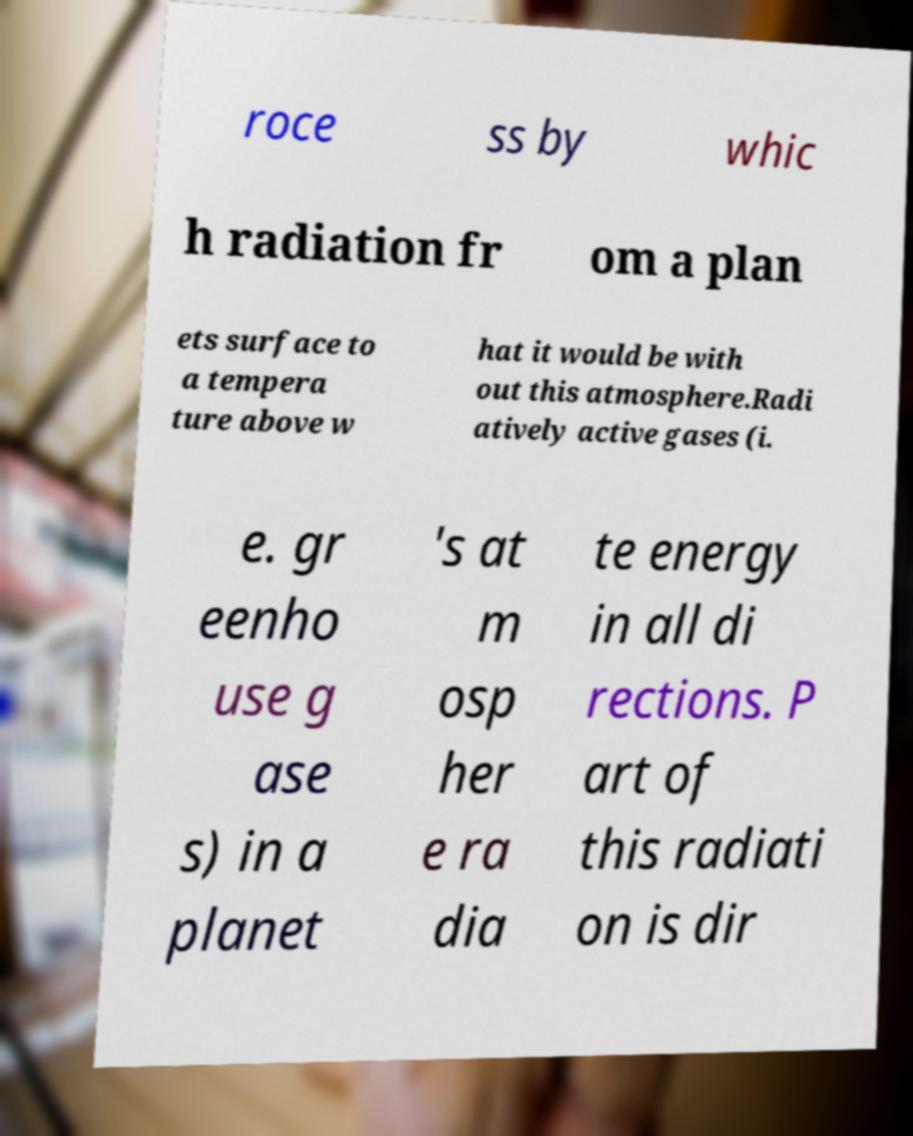Can you read and provide the text displayed in the image?This photo seems to have some interesting text. Can you extract and type it out for me? roce ss by whic h radiation fr om a plan ets surface to a tempera ture above w hat it would be with out this atmosphere.Radi atively active gases (i. e. gr eenho use g ase s) in a planet 's at m osp her e ra dia te energy in all di rections. P art of this radiati on is dir 